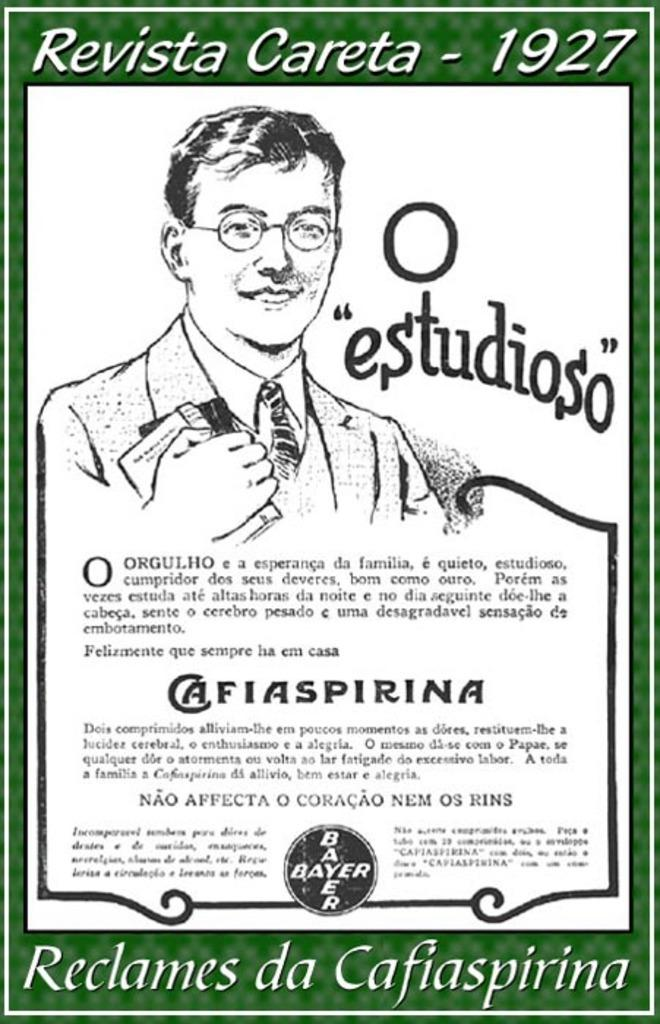What is the main subject of the image? There is a poster in the image. What is depicted on the poster? The poster contains a depiction of a man. Where is text located on the poster? There is text written on the bottom, right, and top of the picture. How many balls can be seen in the image? There are no balls present in the image; it features a poster with a depiction of a man and text. What type of bun is being held by the man in the image? There is no man holding a bun in the image; it only shows a poster with a depiction of a man and text. 